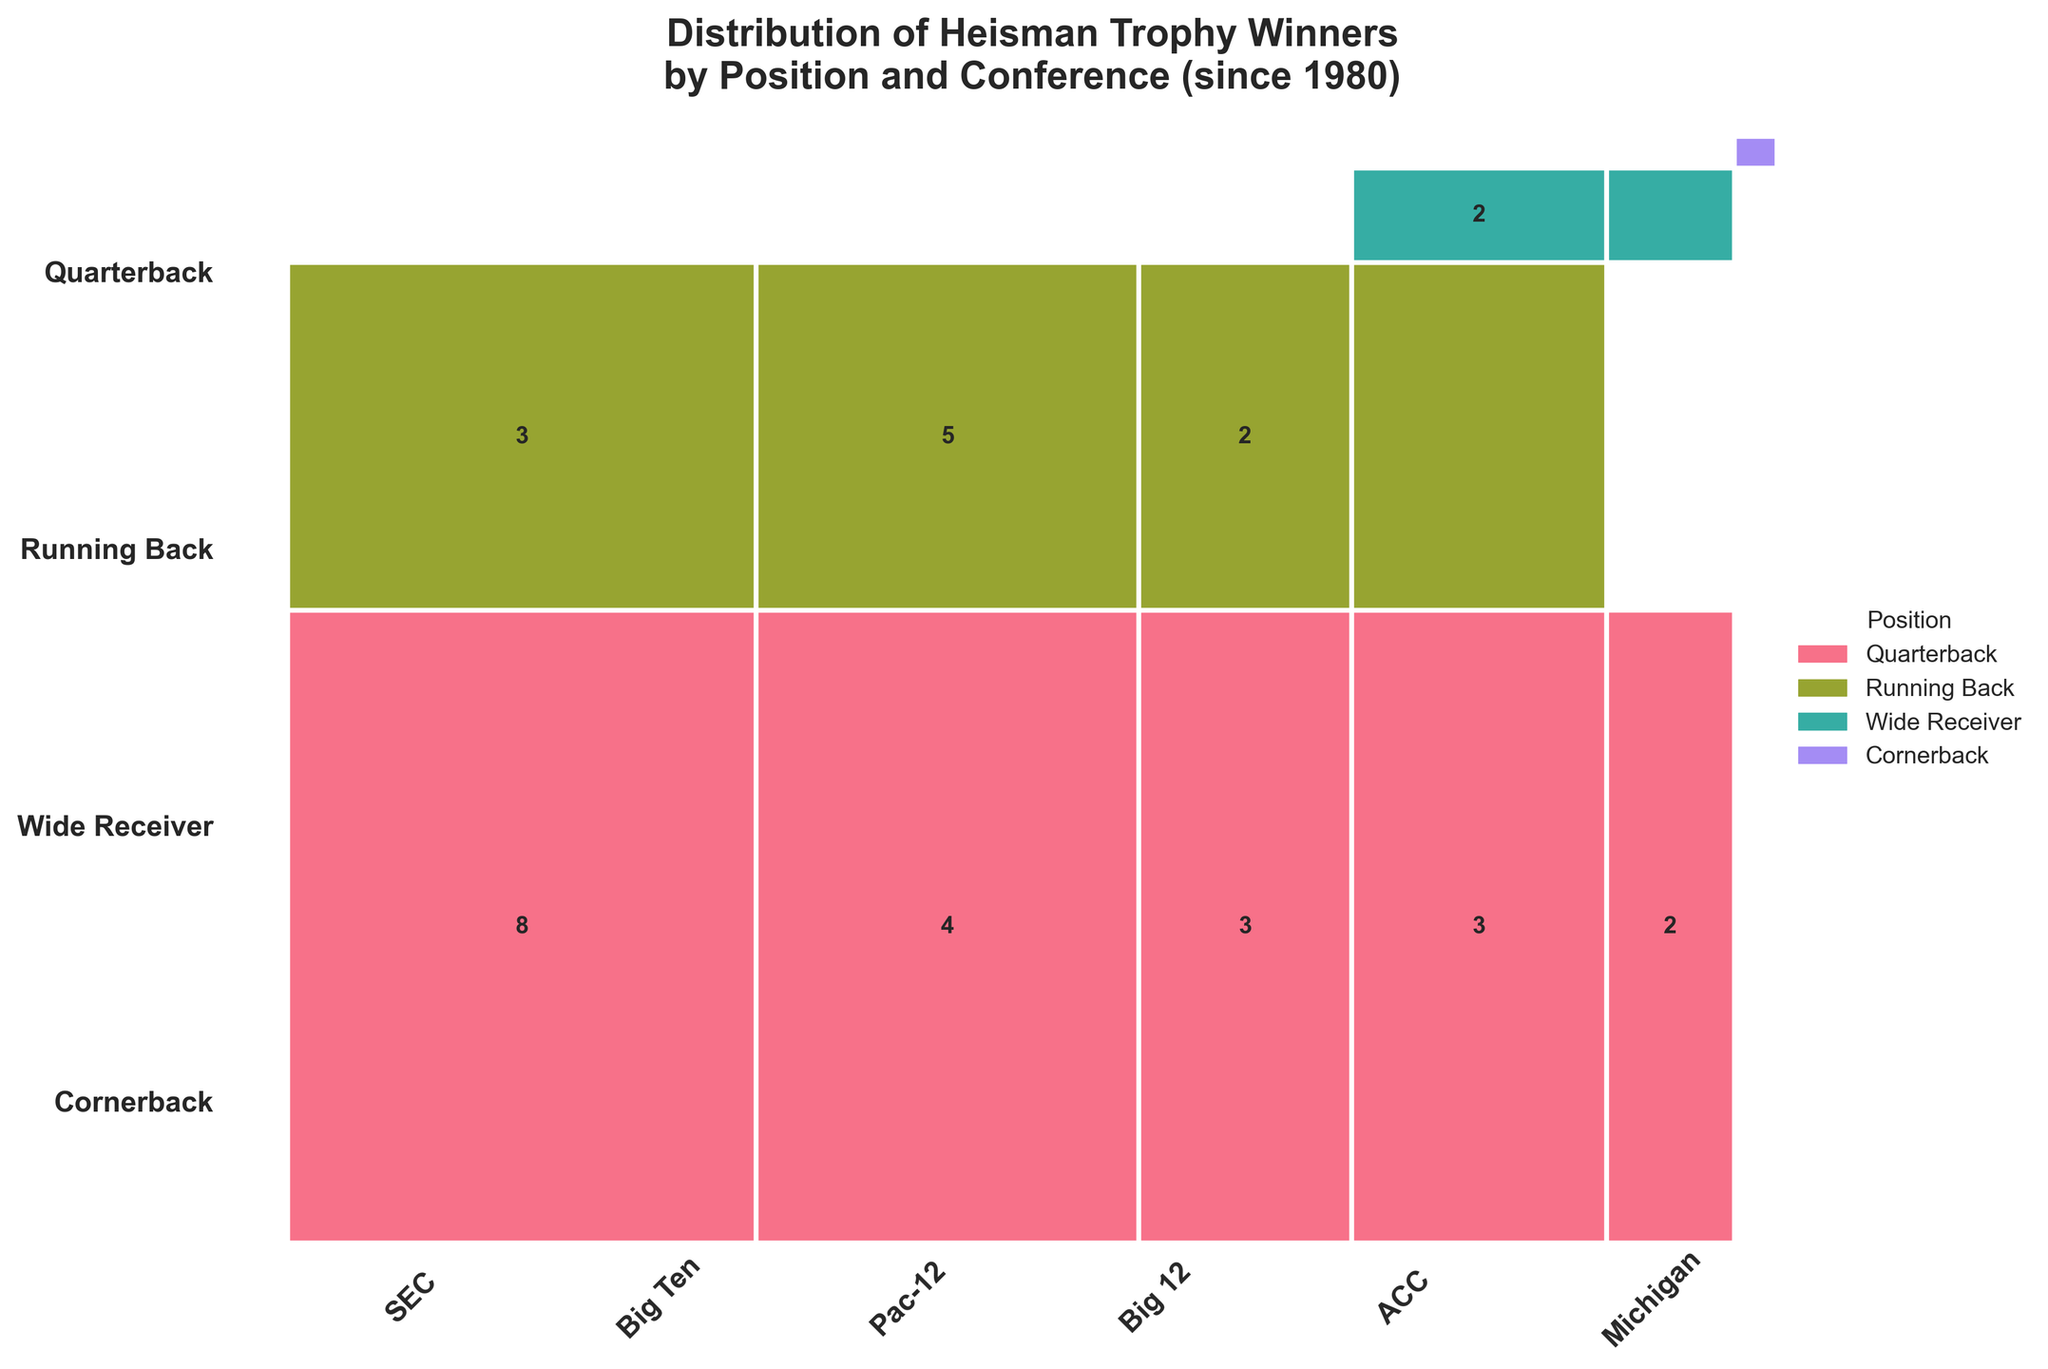Which position has won the most Heisman Trophies since 1980? By observing the relative sizes of the rectangles, the position with the largest total height across different conferences is the quarterback.
Answer: Quarterback How many Heisman Trophies have been won by players from the SEC conference? To get the total count for the SEC conference, add up all the individual counts for this conference: 8 (Quarterbacks) + 3 (Running Backs) = 11.
Answer: 11 What is the smallest category in terms of Heisman Trophy winners by position and conference? The smallest category in terms of count is the Cornerback from Michigan, with only 1 winner.
Answer: Cornerback, Michigan Which conference has the greatest diversity in Heisman Trophy-winning positions? To determine this, observe which conference has the most different positions represented. The Big 12 conference has winners in three different positions: Quarterback, Running Back, and Wide Receiver.
Answer: Big 12 Has a Wide Receiver from the ACC ever won the Heisman Trophy? From the plot, there is a rectangle representing Wide Receivers in the ACC labeled with the count of 1, indicating at least one Wide Receiver from the ACC has won the trophy.
Answer: Yes Which conference has produced more Heisman-winning Running Backs: SEC or Big Ten? Compare the totals for Running Backs in each conference: SEC has 3 and Big Ten has 5. Thus, the Big Ten has produced more Heisman-winning Running Backs.
Answer: Big Ten By how much do Heisman-winning Quarterbacks outnumber Running Backs? Calculate the total count for Quarterbacks (8+4+3+3+2) and Running Backs (5+3+2+1), then find the difference: 20 - 11 = 9.
Answer: 9 Which position has zero Heisman Trophy winners from either the Big Ten or Pac-12 conferences? By examining the plot, there are no Wide Receiver Heisman winners in either the Big Ten or the Pac-12 conference.
Answer: Wide Receiver How many more Heisman Trophies have SEC Quarterbacks won compared to Pac-12 Quarterbacks? Subtract the count of Pac-12 Quarterbacks (3) from SEC Quarterbacks (8): 8 - 3 = 5.
Answer: 5 